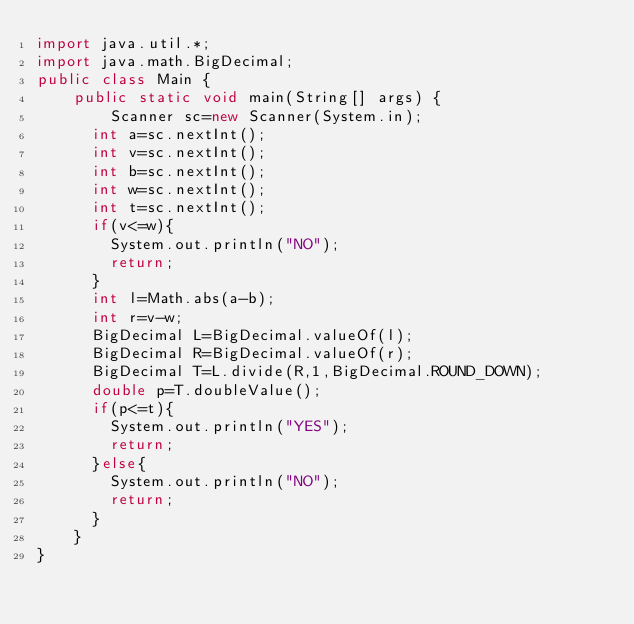<code> <loc_0><loc_0><loc_500><loc_500><_Java_>import java.util.*;
import java.math.BigDecimal;
public class Main {
	public static void main(String[] args) {
		Scanner sc=new Scanner(System.in);
      int a=sc.nextInt();
      int v=sc.nextInt();
      int b=sc.nextInt();
      int w=sc.nextInt();
      int t=sc.nextInt();
      if(v<=w){
      	System.out.println("NO");
        return;
      }
      int l=Math.abs(a-b);
      int r=v-w;
      BigDecimal L=BigDecimal.valueOf(l);
      BigDecimal R=BigDecimal.valueOf(r);
      BigDecimal T=L.divide(R,1,BigDecimal.ROUND_DOWN);
      double p=T.doubleValue();
      if(p<=t){
      	System.out.println("YES");
      	return;
      }else{
      	System.out.println("NO");
        return;
      }
    }
}</code> 